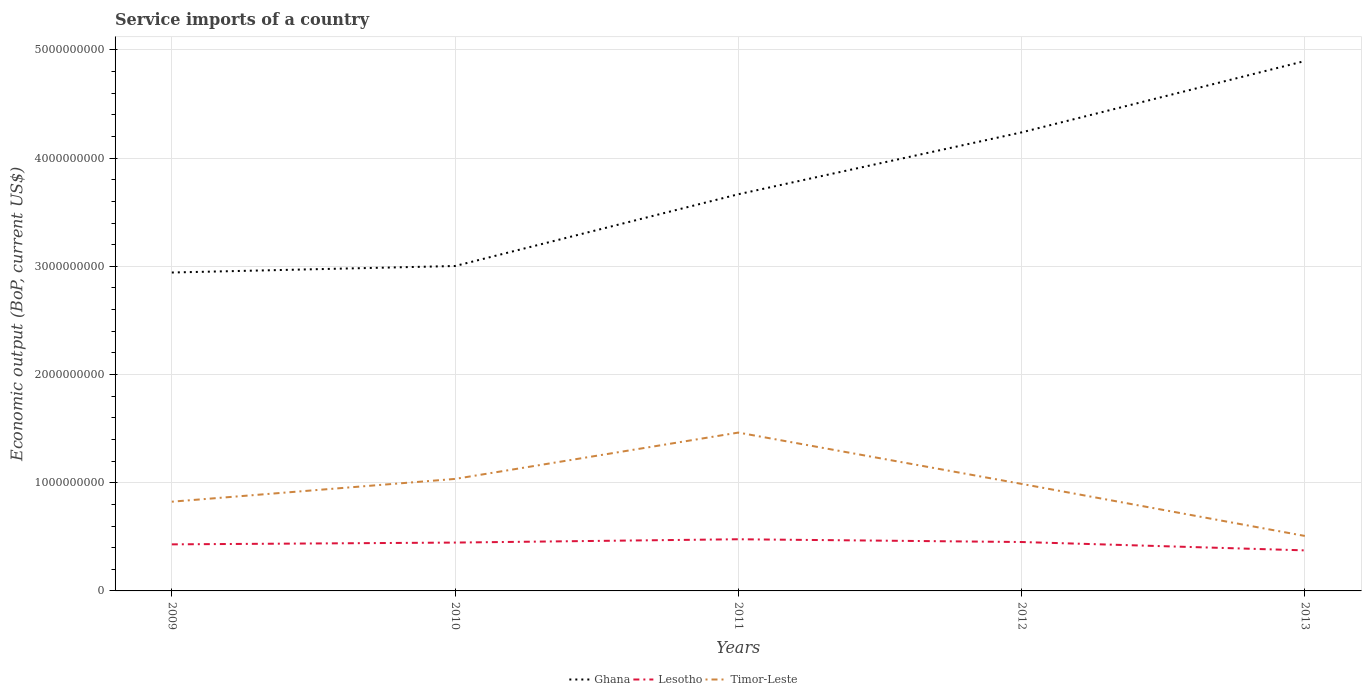Does the line corresponding to Ghana intersect with the line corresponding to Lesotho?
Keep it short and to the point. No. Is the number of lines equal to the number of legend labels?
Provide a short and direct response. Yes. Across all years, what is the maximum service imports in Ghana?
Offer a terse response. 2.94e+09. What is the total service imports in Lesotho in the graph?
Ensure brevity in your answer.  -3.07e+07. What is the difference between the highest and the second highest service imports in Ghana?
Provide a succinct answer. 1.95e+09. How many lines are there?
Your answer should be very brief. 3. How many legend labels are there?
Provide a short and direct response. 3. What is the title of the graph?
Your response must be concise. Service imports of a country. What is the label or title of the Y-axis?
Your answer should be compact. Economic output (BoP, current US$). What is the Economic output (BoP, current US$) in Ghana in 2009?
Offer a very short reply. 2.94e+09. What is the Economic output (BoP, current US$) of Lesotho in 2009?
Your response must be concise. 4.30e+08. What is the Economic output (BoP, current US$) in Timor-Leste in 2009?
Provide a short and direct response. 8.25e+08. What is the Economic output (BoP, current US$) in Ghana in 2010?
Your response must be concise. 3.00e+09. What is the Economic output (BoP, current US$) of Lesotho in 2010?
Your answer should be compact. 4.47e+08. What is the Economic output (BoP, current US$) of Timor-Leste in 2010?
Make the answer very short. 1.04e+09. What is the Economic output (BoP, current US$) of Ghana in 2011?
Give a very brief answer. 3.67e+09. What is the Economic output (BoP, current US$) of Lesotho in 2011?
Your answer should be very brief. 4.78e+08. What is the Economic output (BoP, current US$) in Timor-Leste in 2011?
Ensure brevity in your answer.  1.46e+09. What is the Economic output (BoP, current US$) of Ghana in 2012?
Your response must be concise. 4.24e+09. What is the Economic output (BoP, current US$) in Lesotho in 2012?
Your answer should be very brief. 4.52e+08. What is the Economic output (BoP, current US$) in Timor-Leste in 2012?
Provide a short and direct response. 9.89e+08. What is the Economic output (BoP, current US$) of Ghana in 2013?
Keep it short and to the point. 4.90e+09. What is the Economic output (BoP, current US$) of Lesotho in 2013?
Your response must be concise. 3.75e+08. What is the Economic output (BoP, current US$) in Timor-Leste in 2013?
Make the answer very short. 5.08e+08. Across all years, what is the maximum Economic output (BoP, current US$) of Ghana?
Offer a terse response. 4.90e+09. Across all years, what is the maximum Economic output (BoP, current US$) in Lesotho?
Give a very brief answer. 4.78e+08. Across all years, what is the maximum Economic output (BoP, current US$) of Timor-Leste?
Your response must be concise. 1.46e+09. Across all years, what is the minimum Economic output (BoP, current US$) in Ghana?
Offer a very short reply. 2.94e+09. Across all years, what is the minimum Economic output (BoP, current US$) in Lesotho?
Offer a very short reply. 3.75e+08. Across all years, what is the minimum Economic output (BoP, current US$) in Timor-Leste?
Your response must be concise. 5.08e+08. What is the total Economic output (BoP, current US$) of Ghana in the graph?
Ensure brevity in your answer.  1.87e+1. What is the total Economic output (BoP, current US$) of Lesotho in the graph?
Your answer should be compact. 2.18e+09. What is the total Economic output (BoP, current US$) in Timor-Leste in the graph?
Your answer should be very brief. 4.82e+09. What is the difference between the Economic output (BoP, current US$) of Ghana in 2009 and that in 2010?
Your answer should be compact. -6.01e+07. What is the difference between the Economic output (BoP, current US$) of Lesotho in 2009 and that in 2010?
Your response must be concise. -1.66e+07. What is the difference between the Economic output (BoP, current US$) in Timor-Leste in 2009 and that in 2010?
Give a very brief answer. -2.11e+08. What is the difference between the Economic output (BoP, current US$) of Ghana in 2009 and that in 2011?
Offer a terse response. -7.23e+08. What is the difference between the Economic output (BoP, current US$) of Lesotho in 2009 and that in 2011?
Provide a short and direct response. -4.72e+07. What is the difference between the Economic output (BoP, current US$) of Timor-Leste in 2009 and that in 2011?
Give a very brief answer. -6.39e+08. What is the difference between the Economic output (BoP, current US$) in Ghana in 2009 and that in 2012?
Your answer should be compact. -1.30e+09. What is the difference between the Economic output (BoP, current US$) in Lesotho in 2009 and that in 2012?
Make the answer very short. -2.17e+07. What is the difference between the Economic output (BoP, current US$) of Timor-Leste in 2009 and that in 2012?
Your answer should be compact. -1.64e+08. What is the difference between the Economic output (BoP, current US$) in Ghana in 2009 and that in 2013?
Your response must be concise. -1.95e+09. What is the difference between the Economic output (BoP, current US$) of Lesotho in 2009 and that in 2013?
Your answer should be compact. 5.55e+07. What is the difference between the Economic output (BoP, current US$) of Timor-Leste in 2009 and that in 2013?
Your answer should be very brief. 3.17e+08. What is the difference between the Economic output (BoP, current US$) in Ghana in 2010 and that in 2011?
Keep it short and to the point. -6.63e+08. What is the difference between the Economic output (BoP, current US$) of Lesotho in 2010 and that in 2011?
Give a very brief answer. -3.07e+07. What is the difference between the Economic output (BoP, current US$) in Timor-Leste in 2010 and that in 2011?
Your answer should be very brief. -4.28e+08. What is the difference between the Economic output (BoP, current US$) in Ghana in 2010 and that in 2012?
Provide a short and direct response. -1.24e+09. What is the difference between the Economic output (BoP, current US$) of Lesotho in 2010 and that in 2012?
Keep it short and to the point. -5.14e+06. What is the difference between the Economic output (BoP, current US$) of Timor-Leste in 2010 and that in 2012?
Your response must be concise. 4.60e+07. What is the difference between the Economic output (BoP, current US$) of Ghana in 2010 and that in 2013?
Ensure brevity in your answer.  -1.89e+09. What is the difference between the Economic output (BoP, current US$) in Lesotho in 2010 and that in 2013?
Keep it short and to the point. 7.21e+07. What is the difference between the Economic output (BoP, current US$) in Timor-Leste in 2010 and that in 2013?
Your answer should be compact. 5.27e+08. What is the difference between the Economic output (BoP, current US$) of Ghana in 2011 and that in 2012?
Your response must be concise. -5.72e+08. What is the difference between the Economic output (BoP, current US$) of Lesotho in 2011 and that in 2012?
Your response must be concise. 2.55e+07. What is the difference between the Economic output (BoP, current US$) of Timor-Leste in 2011 and that in 2012?
Offer a very short reply. 4.74e+08. What is the difference between the Economic output (BoP, current US$) in Ghana in 2011 and that in 2013?
Your answer should be very brief. -1.23e+09. What is the difference between the Economic output (BoP, current US$) in Lesotho in 2011 and that in 2013?
Your answer should be very brief. 1.03e+08. What is the difference between the Economic output (BoP, current US$) in Timor-Leste in 2011 and that in 2013?
Offer a terse response. 9.55e+08. What is the difference between the Economic output (BoP, current US$) of Ghana in 2012 and that in 2013?
Your answer should be very brief. -6.59e+08. What is the difference between the Economic output (BoP, current US$) in Lesotho in 2012 and that in 2013?
Offer a terse response. 7.72e+07. What is the difference between the Economic output (BoP, current US$) of Timor-Leste in 2012 and that in 2013?
Provide a short and direct response. 4.81e+08. What is the difference between the Economic output (BoP, current US$) of Ghana in 2009 and the Economic output (BoP, current US$) of Lesotho in 2010?
Give a very brief answer. 2.50e+09. What is the difference between the Economic output (BoP, current US$) of Ghana in 2009 and the Economic output (BoP, current US$) of Timor-Leste in 2010?
Provide a succinct answer. 1.91e+09. What is the difference between the Economic output (BoP, current US$) of Lesotho in 2009 and the Economic output (BoP, current US$) of Timor-Leste in 2010?
Keep it short and to the point. -6.05e+08. What is the difference between the Economic output (BoP, current US$) in Ghana in 2009 and the Economic output (BoP, current US$) in Lesotho in 2011?
Make the answer very short. 2.47e+09. What is the difference between the Economic output (BoP, current US$) in Ghana in 2009 and the Economic output (BoP, current US$) in Timor-Leste in 2011?
Provide a short and direct response. 1.48e+09. What is the difference between the Economic output (BoP, current US$) in Lesotho in 2009 and the Economic output (BoP, current US$) in Timor-Leste in 2011?
Ensure brevity in your answer.  -1.03e+09. What is the difference between the Economic output (BoP, current US$) of Ghana in 2009 and the Economic output (BoP, current US$) of Lesotho in 2012?
Your response must be concise. 2.49e+09. What is the difference between the Economic output (BoP, current US$) in Ghana in 2009 and the Economic output (BoP, current US$) in Timor-Leste in 2012?
Give a very brief answer. 1.95e+09. What is the difference between the Economic output (BoP, current US$) in Lesotho in 2009 and the Economic output (BoP, current US$) in Timor-Leste in 2012?
Offer a terse response. -5.59e+08. What is the difference between the Economic output (BoP, current US$) of Ghana in 2009 and the Economic output (BoP, current US$) of Lesotho in 2013?
Keep it short and to the point. 2.57e+09. What is the difference between the Economic output (BoP, current US$) of Ghana in 2009 and the Economic output (BoP, current US$) of Timor-Leste in 2013?
Keep it short and to the point. 2.43e+09. What is the difference between the Economic output (BoP, current US$) of Lesotho in 2009 and the Economic output (BoP, current US$) of Timor-Leste in 2013?
Keep it short and to the point. -7.78e+07. What is the difference between the Economic output (BoP, current US$) of Ghana in 2010 and the Economic output (BoP, current US$) of Lesotho in 2011?
Offer a terse response. 2.53e+09. What is the difference between the Economic output (BoP, current US$) of Ghana in 2010 and the Economic output (BoP, current US$) of Timor-Leste in 2011?
Offer a very short reply. 1.54e+09. What is the difference between the Economic output (BoP, current US$) in Lesotho in 2010 and the Economic output (BoP, current US$) in Timor-Leste in 2011?
Keep it short and to the point. -1.02e+09. What is the difference between the Economic output (BoP, current US$) in Ghana in 2010 and the Economic output (BoP, current US$) in Lesotho in 2012?
Offer a very short reply. 2.55e+09. What is the difference between the Economic output (BoP, current US$) in Ghana in 2010 and the Economic output (BoP, current US$) in Timor-Leste in 2012?
Ensure brevity in your answer.  2.01e+09. What is the difference between the Economic output (BoP, current US$) in Lesotho in 2010 and the Economic output (BoP, current US$) in Timor-Leste in 2012?
Offer a very short reply. -5.42e+08. What is the difference between the Economic output (BoP, current US$) in Ghana in 2010 and the Economic output (BoP, current US$) in Lesotho in 2013?
Give a very brief answer. 2.63e+09. What is the difference between the Economic output (BoP, current US$) in Ghana in 2010 and the Economic output (BoP, current US$) in Timor-Leste in 2013?
Your answer should be very brief. 2.50e+09. What is the difference between the Economic output (BoP, current US$) in Lesotho in 2010 and the Economic output (BoP, current US$) in Timor-Leste in 2013?
Provide a short and direct response. -6.13e+07. What is the difference between the Economic output (BoP, current US$) of Ghana in 2011 and the Economic output (BoP, current US$) of Lesotho in 2012?
Provide a short and direct response. 3.21e+09. What is the difference between the Economic output (BoP, current US$) in Ghana in 2011 and the Economic output (BoP, current US$) in Timor-Leste in 2012?
Your answer should be compact. 2.68e+09. What is the difference between the Economic output (BoP, current US$) in Lesotho in 2011 and the Economic output (BoP, current US$) in Timor-Leste in 2012?
Provide a succinct answer. -5.12e+08. What is the difference between the Economic output (BoP, current US$) of Ghana in 2011 and the Economic output (BoP, current US$) of Lesotho in 2013?
Offer a very short reply. 3.29e+09. What is the difference between the Economic output (BoP, current US$) of Ghana in 2011 and the Economic output (BoP, current US$) of Timor-Leste in 2013?
Offer a very short reply. 3.16e+09. What is the difference between the Economic output (BoP, current US$) in Lesotho in 2011 and the Economic output (BoP, current US$) in Timor-Leste in 2013?
Give a very brief answer. -3.06e+07. What is the difference between the Economic output (BoP, current US$) in Ghana in 2012 and the Economic output (BoP, current US$) in Lesotho in 2013?
Make the answer very short. 3.86e+09. What is the difference between the Economic output (BoP, current US$) in Ghana in 2012 and the Economic output (BoP, current US$) in Timor-Leste in 2013?
Offer a terse response. 3.73e+09. What is the difference between the Economic output (BoP, current US$) of Lesotho in 2012 and the Economic output (BoP, current US$) of Timor-Leste in 2013?
Ensure brevity in your answer.  -5.61e+07. What is the average Economic output (BoP, current US$) in Ghana per year?
Keep it short and to the point. 3.75e+09. What is the average Economic output (BoP, current US$) of Lesotho per year?
Offer a very short reply. 4.36e+08. What is the average Economic output (BoP, current US$) in Timor-Leste per year?
Offer a terse response. 9.64e+08. In the year 2009, what is the difference between the Economic output (BoP, current US$) in Ghana and Economic output (BoP, current US$) in Lesotho?
Your response must be concise. 2.51e+09. In the year 2009, what is the difference between the Economic output (BoP, current US$) in Ghana and Economic output (BoP, current US$) in Timor-Leste?
Provide a short and direct response. 2.12e+09. In the year 2009, what is the difference between the Economic output (BoP, current US$) of Lesotho and Economic output (BoP, current US$) of Timor-Leste?
Offer a very short reply. -3.94e+08. In the year 2010, what is the difference between the Economic output (BoP, current US$) of Ghana and Economic output (BoP, current US$) of Lesotho?
Give a very brief answer. 2.56e+09. In the year 2010, what is the difference between the Economic output (BoP, current US$) in Ghana and Economic output (BoP, current US$) in Timor-Leste?
Ensure brevity in your answer.  1.97e+09. In the year 2010, what is the difference between the Economic output (BoP, current US$) in Lesotho and Economic output (BoP, current US$) in Timor-Leste?
Ensure brevity in your answer.  -5.88e+08. In the year 2011, what is the difference between the Economic output (BoP, current US$) of Ghana and Economic output (BoP, current US$) of Lesotho?
Your response must be concise. 3.19e+09. In the year 2011, what is the difference between the Economic output (BoP, current US$) in Ghana and Economic output (BoP, current US$) in Timor-Leste?
Provide a succinct answer. 2.20e+09. In the year 2011, what is the difference between the Economic output (BoP, current US$) of Lesotho and Economic output (BoP, current US$) of Timor-Leste?
Your answer should be compact. -9.86e+08. In the year 2012, what is the difference between the Economic output (BoP, current US$) in Ghana and Economic output (BoP, current US$) in Lesotho?
Provide a short and direct response. 3.79e+09. In the year 2012, what is the difference between the Economic output (BoP, current US$) in Ghana and Economic output (BoP, current US$) in Timor-Leste?
Provide a succinct answer. 3.25e+09. In the year 2012, what is the difference between the Economic output (BoP, current US$) in Lesotho and Economic output (BoP, current US$) in Timor-Leste?
Provide a short and direct response. -5.37e+08. In the year 2013, what is the difference between the Economic output (BoP, current US$) in Ghana and Economic output (BoP, current US$) in Lesotho?
Give a very brief answer. 4.52e+09. In the year 2013, what is the difference between the Economic output (BoP, current US$) of Ghana and Economic output (BoP, current US$) of Timor-Leste?
Offer a terse response. 4.39e+09. In the year 2013, what is the difference between the Economic output (BoP, current US$) of Lesotho and Economic output (BoP, current US$) of Timor-Leste?
Your answer should be very brief. -1.33e+08. What is the ratio of the Economic output (BoP, current US$) in Lesotho in 2009 to that in 2010?
Your answer should be compact. 0.96. What is the ratio of the Economic output (BoP, current US$) in Timor-Leste in 2009 to that in 2010?
Your answer should be very brief. 0.8. What is the ratio of the Economic output (BoP, current US$) in Ghana in 2009 to that in 2011?
Give a very brief answer. 0.8. What is the ratio of the Economic output (BoP, current US$) of Lesotho in 2009 to that in 2011?
Your response must be concise. 0.9. What is the ratio of the Economic output (BoP, current US$) of Timor-Leste in 2009 to that in 2011?
Provide a succinct answer. 0.56. What is the ratio of the Economic output (BoP, current US$) of Ghana in 2009 to that in 2012?
Provide a short and direct response. 0.69. What is the ratio of the Economic output (BoP, current US$) in Timor-Leste in 2009 to that in 2012?
Ensure brevity in your answer.  0.83. What is the ratio of the Economic output (BoP, current US$) in Ghana in 2009 to that in 2013?
Offer a terse response. 0.6. What is the ratio of the Economic output (BoP, current US$) in Lesotho in 2009 to that in 2013?
Give a very brief answer. 1.15. What is the ratio of the Economic output (BoP, current US$) of Timor-Leste in 2009 to that in 2013?
Keep it short and to the point. 1.62. What is the ratio of the Economic output (BoP, current US$) in Ghana in 2010 to that in 2011?
Offer a very short reply. 0.82. What is the ratio of the Economic output (BoP, current US$) of Lesotho in 2010 to that in 2011?
Your answer should be compact. 0.94. What is the ratio of the Economic output (BoP, current US$) of Timor-Leste in 2010 to that in 2011?
Offer a very short reply. 0.71. What is the ratio of the Economic output (BoP, current US$) in Ghana in 2010 to that in 2012?
Ensure brevity in your answer.  0.71. What is the ratio of the Economic output (BoP, current US$) in Timor-Leste in 2010 to that in 2012?
Offer a terse response. 1.05. What is the ratio of the Economic output (BoP, current US$) in Ghana in 2010 to that in 2013?
Keep it short and to the point. 0.61. What is the ratio of the Economic output (BoP, current US$) in Lesotho in 2010 to that in 2013?
Make the answer very short. 1.19. What is the ratio of the Economic output (BoP, current US$) in Timor-Leste in 2010 to that in 2013?
Your answer should be very brief. 2.04. What is the ratio of the Economic output (BoP, current US$) of Ghana in 2011 to that in 2012?
Offer a very short reply. 0.87. What is the ratio of the Economic output (BoP, current US$) in Lesotho in 2011 to that in 2012?
Your response must be concise. 1.06. What is the ratio of the Economic output (BoP, current US$) of Timor-Leste in 2011 to that in 2012?
Your answer should be very brief. 1.48. What is the ratio of the Economic output (BoP, current US$) of Ghana in 2011 to that in 2013?
Make the answer very short. 0.75. What is the ratio of the Economic output (BoP, current US$) of Lesotho in 2011 to that in 2013?
Offer a very short reply. 1.27. What is the ratio of the Economic output (BoP, current US$) of Timor-Leste in 2011 to that in 2013?
Give a very brief answer. 2.88. What is the ratio of the Economic output (BoP, current US$) of Ghana in 2012 to that in 2013?
Offer a very short reply. 0.87. What is the ratio of the Economic output (BoP, current US$) of Lesotho in 2012 to that in 2013?
Offer a terse response. 1.21. What is the ratio of the Economic output (BoP, current US$) of Timor-Leste in 2012 to that in 2013?
Your answer should be very brief. 1.95. What is the difference between the highest and the second highest Economic output (BoP, current US$) in Ghana?
Ensure brevity in your answer.  6.59e+08. What is the difference between the highest and the second highest Economic output (BoP, current US$) in Lesotho?
Offer a terse response. 2.55e+07. What is the difference between the highest and the second highest Economic output (BoP, current US$) of Timor-Leste?
Your answer should be very brief. 4.28e+08. What is the difference between the highest and the lowest Economic output (BoP, current US$) of Ghana?
Ensure brevity in your answer.  1.95e+09. What is the difference between the highest and the lowest Economic output (BoP, current US$) in Lesotho?
Offer a very short reply. 1.03e+08. What is the difference between the highest and the lowest Economic output (BoP, current US$) of Timor-Leste?
Give a very brief answer. 9.55e+08. 